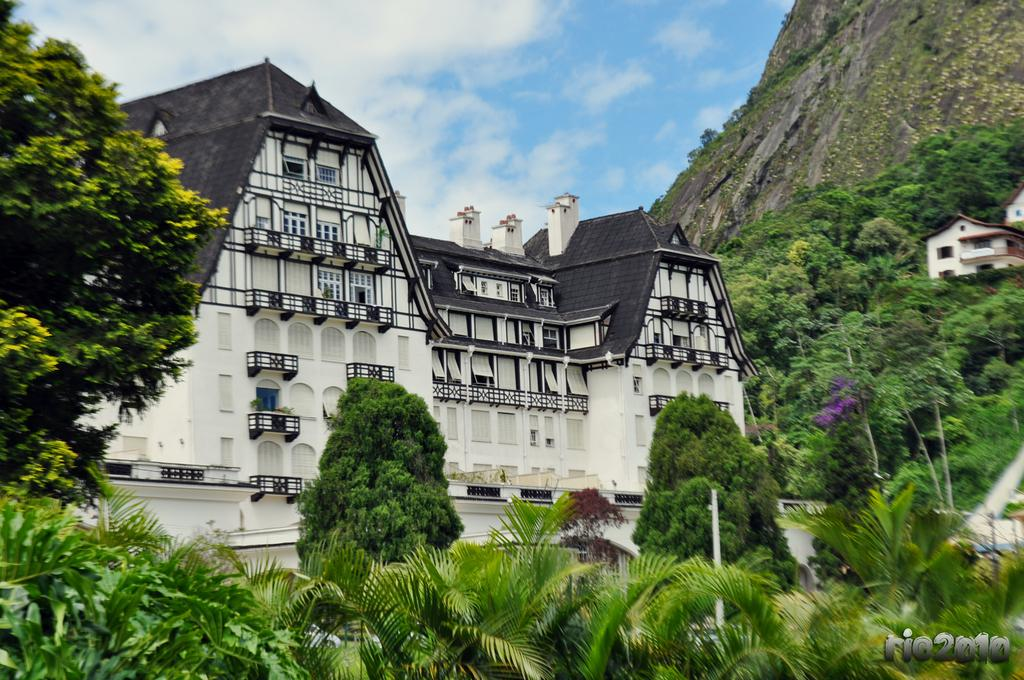What type of natural elements can be seen in the image? There are trees in the image. What type of man-made structures are present in the image? There are buildings and houses in the image. What is the tall, vertical object in the image? There is a pole in the image. What is the condition of the sky in the image? The sky is cloudy in the image. What type of club is being used to hit the ball in the image? There is no ball or club present in the image. Who is the representative of the group in the image? There is no group or representative depicted in the image. 